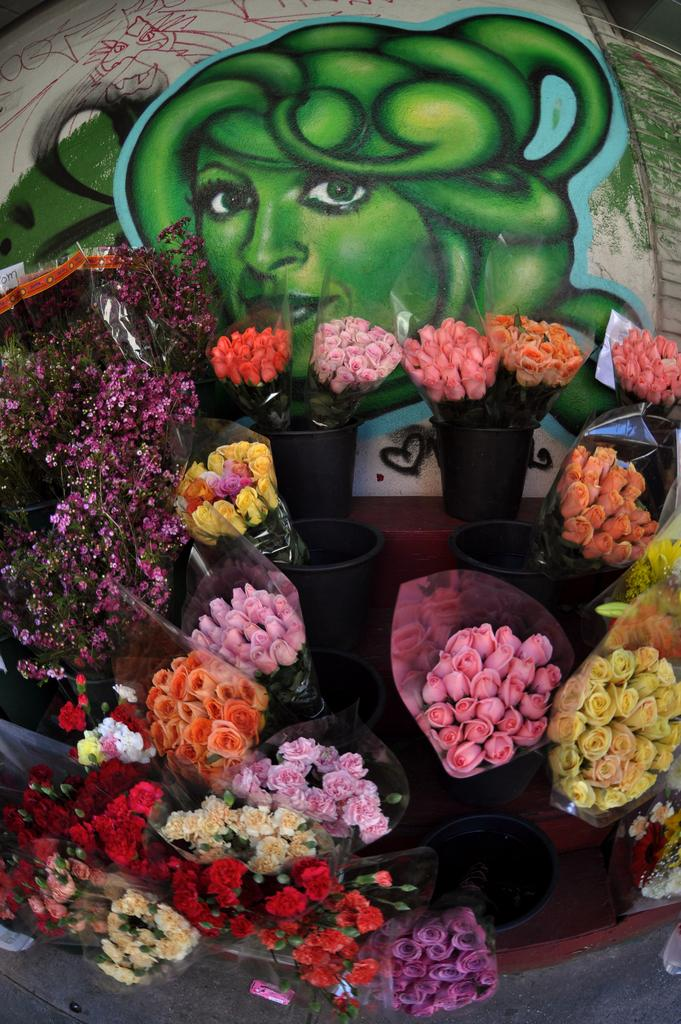What type of decorative items can be seen in the image? There are flower bouquets in the image. What is on the wall in the image? There is a picture on the wall in the image. Can you see any ants crawling on the flower bouquets in the image? There is no indication of ants present on the flower bouquets in the image. What type of ink is used in the picture on the wall? There is no information about the ink used in the picture on the wall in the image. 